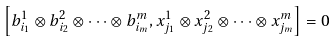<formula> <loc_0><loc_0><loc_500><loc_500>\left [ b _ { i _ { 1 } } ^ { 1 } \otimes b _ { i _ { 2 } } ^ { 2 } \otimes \cdots \otimes b _ { i _ { m } } ^ { m } , x _ { j _ { 1 } } ^ { 1 } \otimes x _ { j _ { 2 } } ^ { 2 } \otimes \cdots \otimes x _ { j _ { m } } ^ { m } \right ] = 0</formula> 